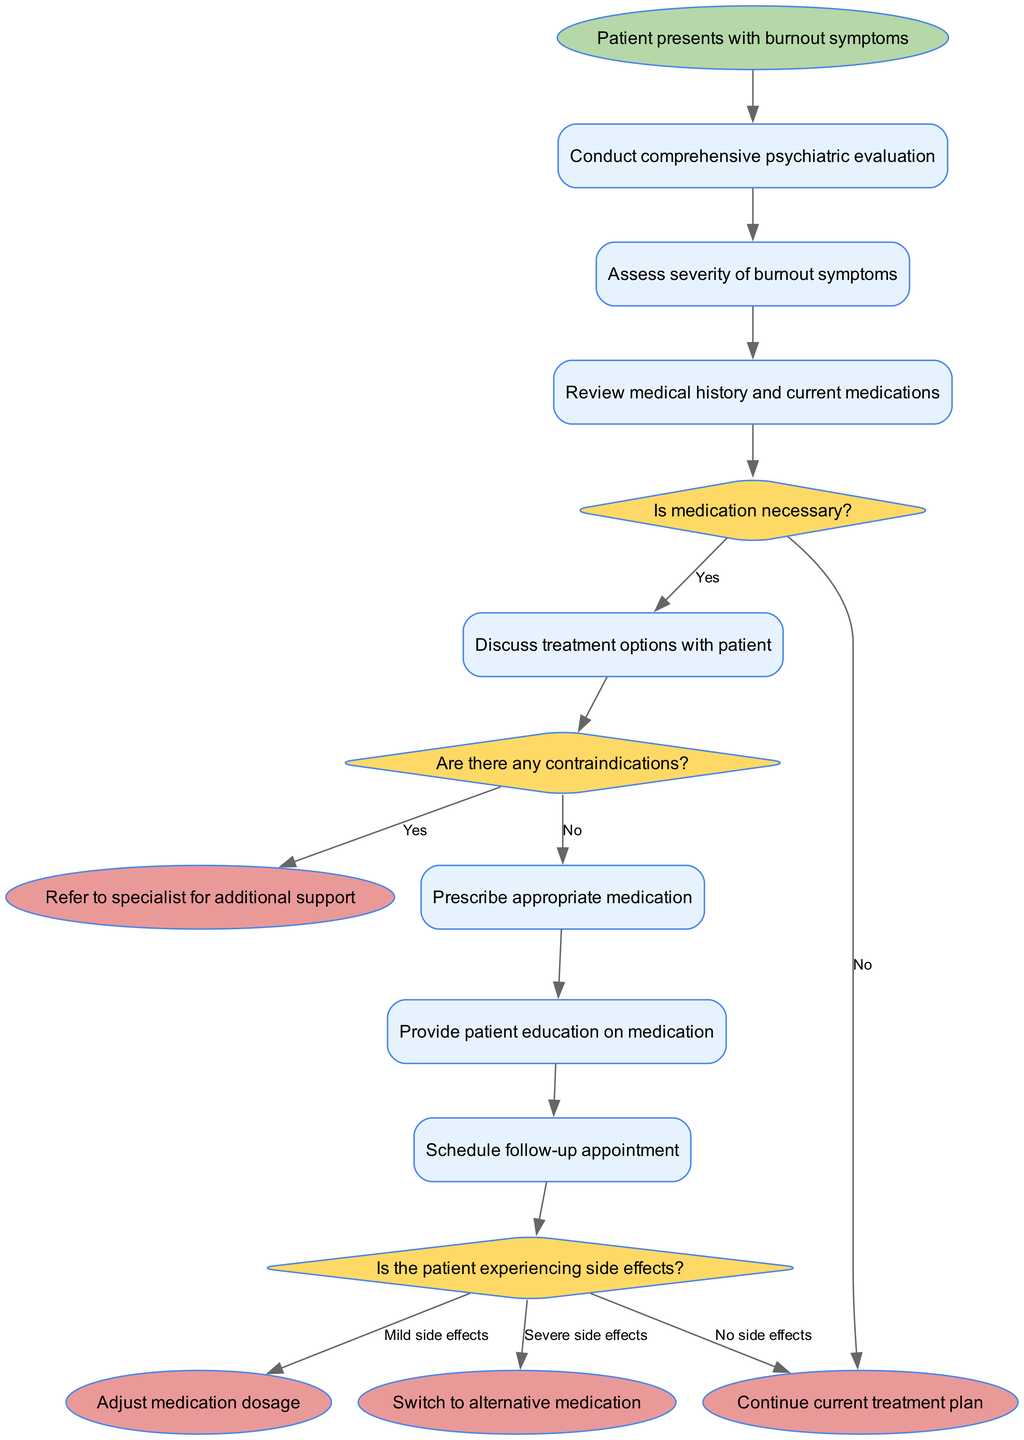What is the starting node of the diagram? The starting node is clearly labeled in the diagram as "Patient presents with burnout symptoms".
Answer: Patient presents with burnout symptoms How many activities are there in the diagram? The diagram lists a total of 7 activities that are part of the medication management workflow.
Answer: 7 What decision follows the activity "Review medical history and current medications"? The decision that follows this activity is "Is medication necessary?".
Answer: Is medication necessary? If the answer to "Is medication necessary?" is No, what is the next step in the workflow? If the answer to "Is medication necessary?" is No, then the workflow proceeds to the end node labeled "Continue current treatment plan".
Answer: Continue current treatment plan What happens after prescribing appropriate medication in the workflow? After prescribing appropriate medication, the next step is to provide patient education on medication.
Answer: Provide patient education on medication What are the possible outcomes related to side effects in the diagram? The possible outcomes related to side effects are "No side effects", "Mild side effects", and "Severe side effects".
Answer: No side effects, Mild side effects, Severe side effects What is the end node if the patient is experiencing severe side effects? If the patient is experiencing severe side effects, the workflow leads to the end node "Refer to specialist for additional support".
Answer: Refer to specialist for additional support What decision is made after providing patient education on medication? The decision made after providing patient education is "Is the patient experiencing side effects?".
Answer: Is the patient experiencing side effects? What happens if the answer to "Are there any contraindications?" is Yes? If the answer to "Are there any contraindications?" is Yes, the workflow goes to the end node "Refer to specialist for additional support".
Answer: Refer to specialist for additional support 